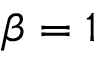Convert formula to latex. <formula><loc_0><loc_0><loc_500><loc_500>\beta = 1</formula> 